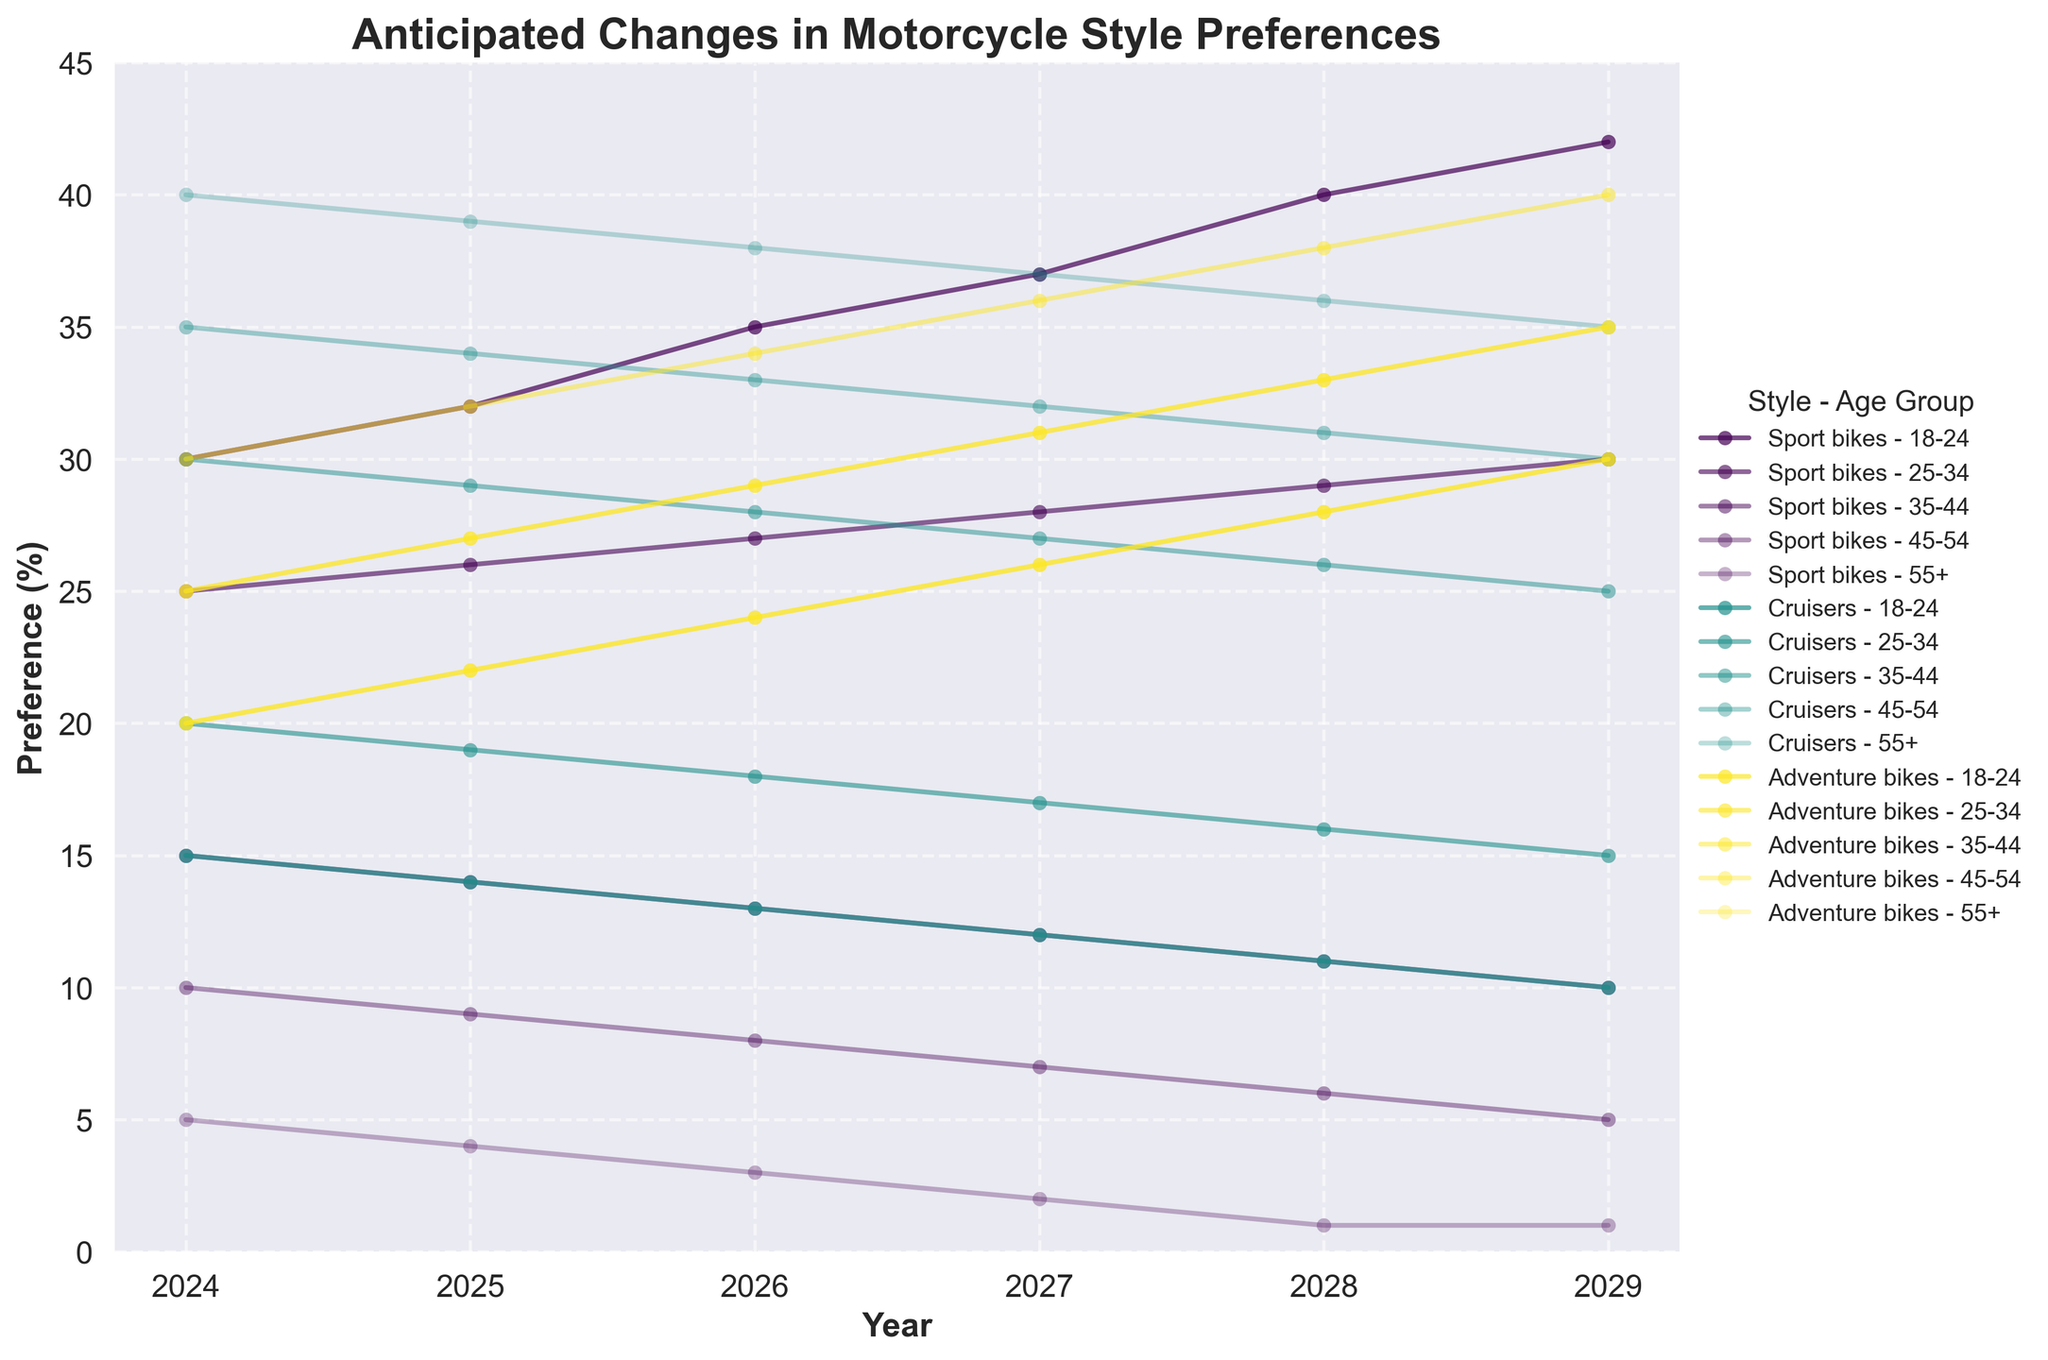What's the title of the figure? The title of the figure is located at the top of the chart, bold and larger in size compared to other text elements.
Answer: Anticipated Changes in Motorcycle Style Preferences Which age group shows a preference increase for Adventure bikes from 2024 to 2029? To identify this, look at the lines representing Adventure bikes, indicating years 2024-2029 and see which age group's line increases.
Answer: All age groups How do anticipated preferences for Sport bikes change for the 35-44 age group over the next 6 years? Check the line for Sport bikes related to the 35-44 age group and observe the trend from 2024 to 2029. This line decreases annually.
Answer: Decrease Which motorcycle style is predicted to have the highest preference among the 55+ age group in 2029? Find and compare the end points (year 2029) of the lines for different styles within the 55+ age group. The line that is highest on the vertical axis represents the highest preference.
Answer: Cruisers What is the difference in preference percentage between Sport bikes and Cruisers for the 45-54 age group in 2026? Look at the data points for Sport bikes and Cruisers for the 45-54 age group in 2026. Subtract the preference value for Sport bikes from that for Cruisers.
Answer: 25% Do any age groups show a decrease in preference for Cruisers over the years? Review the lines representing Cruisers for all age groups and observe whether any of them show a downward trend from the beginning to the end.
Answer: Yes Which age group has a steadier increase in preference for Adventure bikes over the years? Examine the lines representing Adventure bikes for all age groups and observe the consistency in the upward trend.
Answer: 25-34 and 18-24 What's the combined preference for Adventure bikes and Sport bikes for the 18-24 age group in 2029? Extract the data points for Adventure bikes and Sport bikes for the 18-24 age group in 2029 and sum them up.
Answer: 72% How does the preference for Cruisers change from 2024 to 2029 for the 35-44 age group? Identify the line for Cruisers for the 35-44 age group and observe the changes between the start (2024) and end (2029). This line consistently decreases.
Answer: Decrease Which motorcycle style shows the least variation in preference among the 25-34 age group over the 6 years? Review the lines for each motorcycle style in the 25-34 age group and note the range of changes (y-axis values) over the years. The one with the least variation indicates the least change.
Answer: Sport bikes 